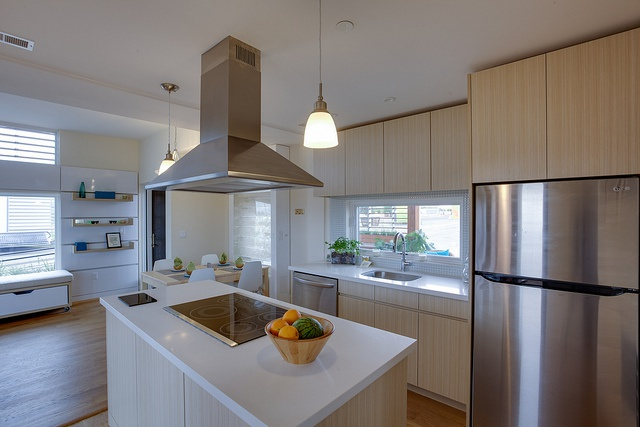Describe the objects in this image and their specific colors. I can see refrigerator in gray, black, and darkgray tones, oven in gray and black tones, bowl in gray, olive, and black tones, dining table in gray and darkgray tones, and potted plant in gray, teal, darkgreen, and black tones in this image. 